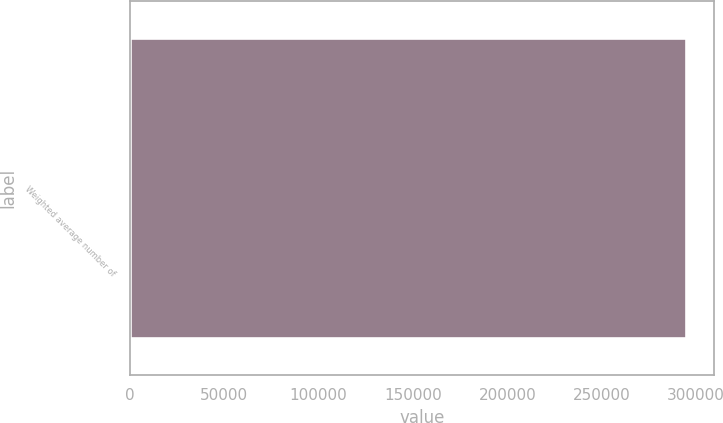<chart> <loc_0><loc_0><loc_500><loc_500><bar_chart><fcel>Weighted average number of<nl><fcel>294630<nl></chart> 